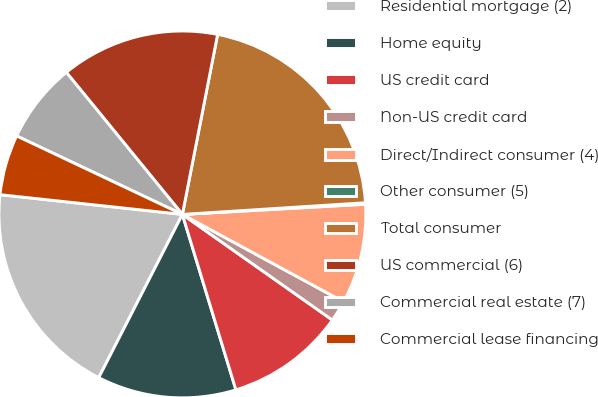<chart> <loc_0><loc_0><loc_500><loc_500><pie_chart><fcel>Residential mortgage (2)<fcel>Home equity<fcel>US credit card<fcel>Non-US credit card<fcel>Direct/Indirect consumer (4)<fcel>Other consumer (5)<fcel>Total consumer<fcel>US commercial (6)<fcel>Commercial real estate (7)<fcel>Commercial lease financing<nl><fcel>19.18%<fcel>12.25%<fcel>10.52%<fcel>1.86%<fcel>8.79%<fcel>0.13%<fcel>20.91%<fcel>13.98%<fcel>7.06%<fcel>5.32%<nl></chart> 